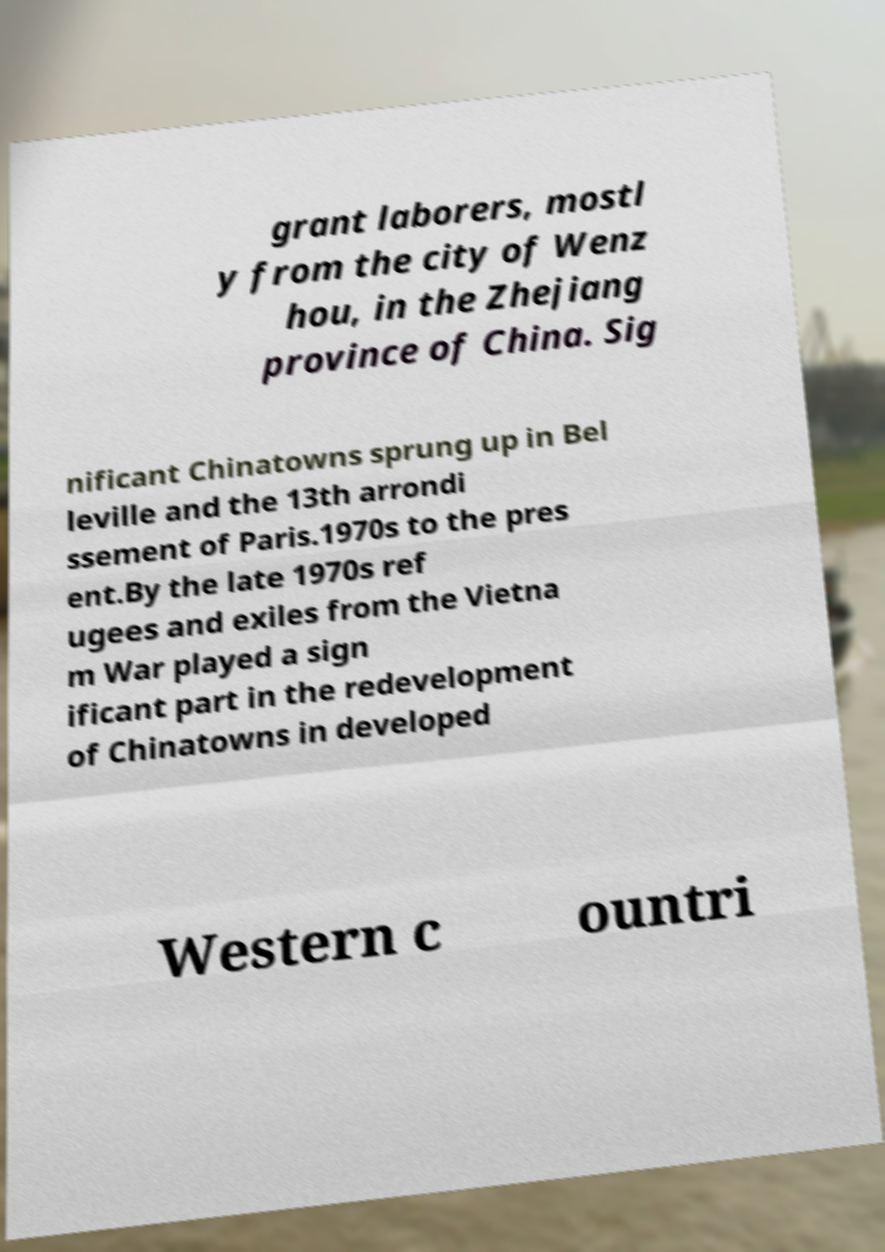Please read and relay the text visible in this image. What does it say? grant laborers, mostl y from the city of Wenz hou, in the Zhejiang province of China. Sig nificant Chinatowns sprung up in Bel leville and the 13th arrondi ssement of Paris.1970s to the pres ent.By the late 1970s ref ugees and exiles from the Vietna m War played a sign ificant part in the redevelopment of Chinatowns in developed Western c ountri 